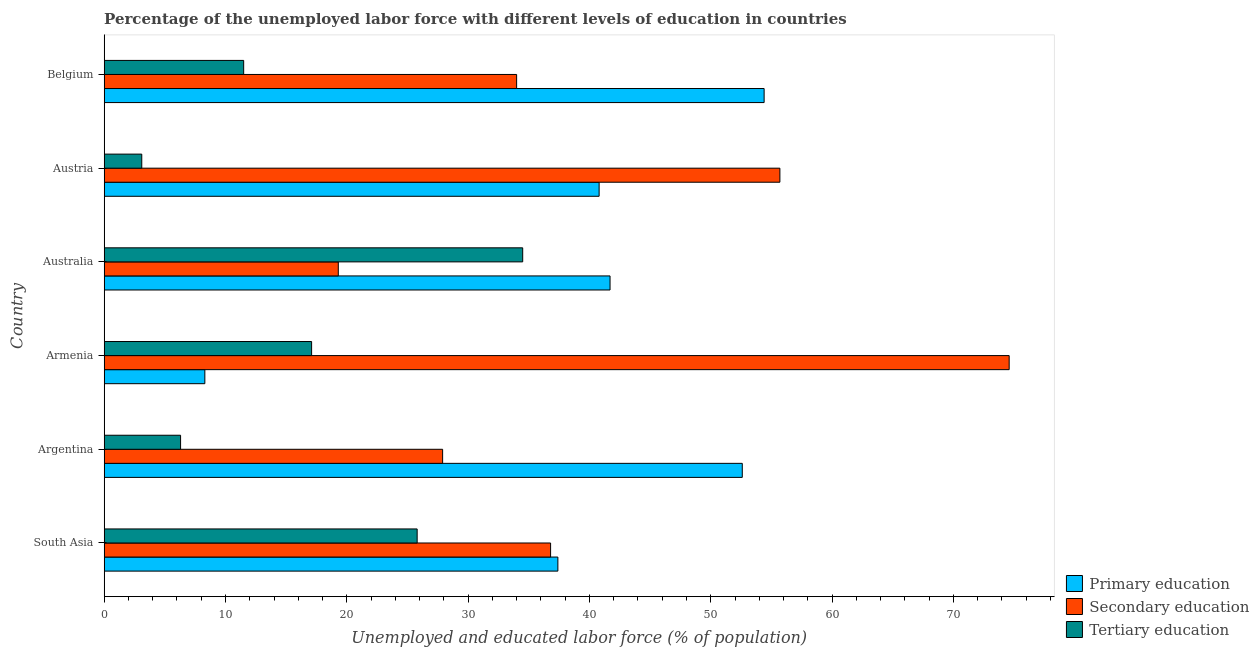How many different coloured bars are there?
Your response must be concise. 3. Are the number of bars on each tick of the Y-axis equal?
Your answer should be very brief. Yes. What is the label of the 5th group of bars from the top?
Offer a very short reply. Argentina. In how many cases, is the number of bars for a given country not equal to the number of legend labels?
Provide a succinct answer. 0. What is the percentage of labor force who received secondary education in Australia?
Offer a terse response. 19.3. Across all countries, what is the maximum percentage of labor force who received secondary education?
Ensure brevity in your answer.  74.6. Across all countries, what is the minimum percentage of labor force who received primary education?
Provide a succinct answer. 8.3. In which country was the percentage of labor force who received primary education maximum?
Your response must be concise. Belgium. What is the total percentage of labor force who received secondary education in the graph?
Offer a terse response. 248.3. What is the difference between the percentage of labor force who received primary education in Belgium and that in South Asia?
Provide a short and direct response. 17. What is the difference between the percentage of labor force who received primary education in Argentina and the percentage of labor force who received tertiary education in Australia?
Keep it short and to the point. 18.1. What is the average percentage of labor force who received primary education per country?
Keep it short and to the point. 39.2. What is the difference between the percentage of labor force who received primary education and percentage of labor force who received secondary education in Belgium?
Offer a terse response. 20.4. What is the ratio of the percentage of labor force who received secondary education in Argentina to that in Australia?
Provide a succinct answer. 1.45. Is the percentage of labor force who received secondary education in Argentina less than that in South Asia?
Provide a short and direct response. Yes. Is the difference between the percentage of labor force who received primary education in Armenia and Belgium greater than the difference between the percentage of labor force who received tertiary education in Armenia and Belgium?
Give a very brief answer. No. What is the difference between the highest and the second highest percentage of labor force who received primary education?
Offer a terse response. 1.8. What is the difference between the highest and the lowest percentage of labor force who received secondary education?
Provide a short and direct response. 55.3. In how many countries, is the percentage of labor force who received secondary education greater than the average percentage of labor force who received secondary education taken over all countries?
Ensure brevity in your answer.  2. What does the 2nd bar from the top in Belgium represents?
Your answer should be compact. Secondary education. What does the 3rd bar from the bottom in Belgium represents?
Offer a very short reply. Tertiary education. Is it the case that in every country, the sum of the percentage of labor force who received primary education and percentage of labor force who received secondary education is greater than the percentage of labor force who received tertiary education?
Your response must be concise. Yes. How many bars are there?
Make the answer very short. 18. How many countries are there in the graph?
Your answer should be very brief. 6. Are the values on the major ticks of X-axis written in scientific E-notation?
Make the answer very short. No. Where does the legend appear in the graph?
Provide a succinct answer. Bottom right. What is the title of the graph?
Offer a terse response. Percentage of the unemployed labor force with different levels of education in countries. Does "Ages 15-64" appear as one of the legend labels in the graph?
Keep it short and to the point. No. What is the label or title of the X-axis?
Offer a very short reply. Unemployed and educated labor force (% of population). What is the Unemployed and educated labor force (% of population) of Primary education in South Asia?
Provide a short and direct response. 37.4. What is the Unemployed and educated labor force (% of population) in Secondary education in South Asia?
Your response must be concise. 36.8. What is the Unemployed and educated labor force (% of population) in Tertiary education in South Asia?
Provide a succinct answer. 25.8. What is the Unemployed and educated labor force (% of population) of Primary education in Argentina?
Provide a short and direct response. 52.6. What is the Unemployed and educated labor force (% of population) of Secondary education in Argentina?
Your response must be concise. 27.9. What is the Unemployed and educated labor force (% of population) of Tertiary education in Argentina?
Provide a short and direct response. 6.3. What is the Unemployed and educated labor force (% of population) in Primary education in Armenia?
Offer a very short reply. 8.3. What is the Unemployed and educated labor force (% of population) of Secondary education in Armenia?
Your answer should be very brief. 74.6. What is the Unemployed and educated labor force (% of population) of Tertiary education in Armenia?
Offer a very short reply. 17.1. What is the Unemployed and educated labor force (% of population) of Primary education in Australia?
Offer a very short reply. 41.7. What is the Unemployed and educated labor force (% of population) in Secondary education in Australia?
Provide a succinct answer. 19.3. What is the Unemployed and educated labor force (% of population) in Tertiary education in Australia?
Your answer should be very brief. 34.5. What is the Unemployed and educated labor force (% of population) of Primary education in Austria?
Ensure brevity in your answer.  40.8. What is the Unemployed and educated labor force (% of population) of Secondary education in Austria?
Your response must be concise. 55.7. What is the Unemployed and educated labor force (% of population) of Tertiary education in Austria?
Your answer should be very brief. 3.1. What is the Unemployed and educated labor force (% of population) of Primary education in Belgium?
Make the answer very short. 54.4. What is the Unemployed and educated labor force (% of population) of Secondary education in Belgium?
Keep it short and to the point. 34. Across all countries, what is the maximum Unemployed and educated labor force (% of population) of Primary education?
Provide a short and direct response. 54.4. Across all countries, what is the maximum Unemployed and educated labor force (% of population) in Secondary education?
Offer a terse response. 74.6. Across all countries, what is the maximum Unemployed and educated labor force (% of population) of Tertiary education?
Provide a short and direct response. 34.5. Across all countries, what is the minimum Unemployed and educated labor force (% of population) in Primary education?
Your answer should be compact. 8.3. Across all countries, what is the minimum Unemployed and educated labor force (% of population) in Secondary education?
Your answer should be compact. 19.3. Across all countries, what is the minimum Unemployed and educated labor force (% of population) in Tertiary education?
Your answer should be compact. 3.1. What is the total Unemployed and educated labor force (% of population) of Primary education in the graph?
Ensure brevity in your answer.  235.2. What is the total Unemployed and educated labor force (% of population) of Secondary education in the graph?
Your response must be concise. 248.3. What is the total Unemployed and educated labor force (% of population) of Tertiary education in the graph?
Make the answer very short. 98.3. What is the difference between the Unemployed and educated labor force (% of population) of Primary education in South Asia and that in Argentina?
Ensure brevity in your answer.  -15.2. What is the difference between the Unemployed and educated labor force (% of population) in Tertiary education in South Asia and that in Argentina?
Your response must be concise. 19.5. What is the difference between the Unemployed and educated labor force (% of population) of Primary education in South Asia and that in Armenia?
Keep it short and to the point. 29.1. What is the difference between the Unemployed and educated labor force (% of population) of Secondary education in South Asia and that in Armenia?
Give a very brief answer. -37.8. What is the difference between the Unemployed and educated labor force (% of population) of Primary education in South Asia and that in Australia?
Ensure brevity in your answer.  -4.3. What is the difference between the Unemployed and educated labor force (% of population) of Tertiary education in South Asia and that in Australia?
Give a very brief answer. -8.7. What is the difference between the Unemployed and educated labor force (% of population) of Secondary education in South Asia and that in Austria?
Ensure brevity in your answer.  -18.9. What is the difference between the Unemployed and educated labor force (% of population) of Tertiary education in South Asia and that in Austria?
Your answer should be very brief. 22.7. What is the difference between the Unemployed and educated labor force (% of population) of Primary education in South Asia and that in Belgium?
Ensure brevity in your answer.  -17. What is the difference between the Unemployed and educated labor force (% of population) of Secondary education in South Asia and that in Belgium?
Your answer should be compact. 2.8. What is the difference between the Unemployed and educated labor force (% of population) of Primary education in Argentina and that in Armenia?
Provide a short and direct response. 44.3. What is the difference between the Unemployed and educated labor force (% of population) of Secondary education in Argentina and that in Armenia?
Your answer should be very brief. -46.7. What is the difference between the Unemployed and educated labor force (% of population) in Secondary education in Argentina and that in Australia?
Offer a very short reply. 8.6. What is the difference between the Unemployed and educated labor force (% of population) in Tertiary education in Argentina and that in Australia?
Ensure brevity in your answer.  -28.2. What is the difference between the Unemployed and educated labor force (% of population) of Secondary education in Argentina and that in Austria?
Your answer should be very brief. -27.8. What is the difference between the Unemployed and educated labor force (% of population) of Primary education in Armenia and that in Australia?
Ensure brevity in your answer.  -33.4. What is the difference between the Unemployed and educated labor force (% of population) in Secondary education in Armenia and that in Australia?
Ensure brevity in your answer.  55.3. What is the difference between the Unemployed and educated labor force (% of population) of Tertiary education in Armenia and that in Australia?
Offer a terse response. -17.4. What is the difference between the Unemployed and educated labor force (% of population) in Primary education in Armenia and that in Austria?
Give a very brief answer. -32.5. What is the difference between the Unemployed and educated labor force (% of population) of Tertiary education in Armenia and that in Austria?
Provide a short and direct response. 14. What is the difference between the Unemployed and educated labor force (% of population) of Primary education in Armenia and that in Belgium?
Your response must be concise. -46.1. What is the difference between the Unemployed and educated labor force (% of population) in Secondary education in Armenia and that in Belgium?
Keep it short and to the point. 40.6. What is the difference between the Unemployed and educated labor force (% of population) of Tertiary education in Armenia and that in Belgium?
Make the answer very short. 5.6. What is the difference between the Unemployed and educated labor force (% of population) in Primary education in Australia and that in Austria?
Provide a succinct answer. 0.9. What is the difference between the Unemployed and educated labor force (% of population) of Secondary education in Australia and that in Austria?
Your answer should be very brief. -36.4. What is the difference between the Unemployed and educated labor force (% of population) in Tertiary education in Australia and that in Austria?
Your answer should be compact. 31.4. What is the difference between the Unemployed and educated labor force (% of population) in Primary education in Australia and that in Belgium?
Offer a very short reply. -12.7. What is the difference between the Unemployed and educated labor force (% of population) in Secondary education in Australia and that in Belgium?
Make the answer very short. -14.7. What is the difference between the Unemployed and educated labor force (% of population) of Primary education in Austria and that in Belgium?
Your response must be concise. -13.6. What is the difference between the Unemployed and educated labor force (% of population) in Secondary education in Austria and that in Belgium?
Offer a terse response. 21.7. What is the difference between the Unemployed and educated labor force (% of population) in Primary education in South Asia and the Unemployed and educated labor force (% of population) in Secondary education in Argentina?
Offer a very short reply. 9.5. What is the difference between the Unemployed and educated labor force (% of population) in Primary education in South Asia and the Unemployed and educated labor force (% of population) in Tertiary education in Argentina?
Make the answer very short. 31.1. What is the difference between the Unemployed and educated labor force (% of population) in Secondary education in South Asia and the Unemployed and educated labor force (% of population) in Tertiary education in Argentina?
Your answer should be compact. 30.5. What is the difference between the Unemployed and educated labor force (% of population) of Primary education in South Asia and the Unemployed and educated labor force (% of population) of Secondary education in Armenia?
Offer a very short reply. -37.2. What is the difference between the Unemployed and educated labor force (% of population) of Primary education in South Asia and the Unemployed and educated labor force (% of population) of Tertiary education in Armenia?
Your response must be concise. 20.3. What is the difference between the Unemployed and educated labor force (% of population) in Primary education in South Asia and the Unemployed and educated labor force (% of population) in Secondary education in Australia?
Give a very brief answer. 18.1. What is the difference between the Unemployed and educated labor force (% of population) of Secondary education in South Asia and the Unemployed and educated labor force (% of population) of Tertiary education in Australia?
Provide a succinct answer. 2.3. What is the difference between the Unemployed and educated labor force (% of population) in Primary education in South Asia and the Unemployed and educated labor force (% of population) in Secondary education in Austria?
Make the answer very short. -18.3. What is the difference between the Unemployed and educated labor force (% of population) of Primary education in South Asia and the Unemployed and educated labor force (% of population) of Tertiary education in Austria?
Offer a terse response. 34.3. What is the difference between the Unemployed and educated labor force (% of population) of Secondary education in South Asia and the Unemployed and educated labor force (% of population) of Tertiary education in Austria?
Make the answer very short. 33.7. What is the difference between the Unemployed and educated labor force (% of population) in Primary education in South Asia and the Unemployed and educated labor force (% of population) in Tertiary education in Belgium?
Offer a terse response. 25.9. What is the difference between the Unemployed and educated labor force (% of population) of Secondary education in South Asia and the Unemployed and educated labor force (% of population) of Tertiary education in Belgium?
Your response must be concise. 25.3. What is the difference between the Unemployed and educated labor force (% of population) in Primary education in Argentina and the Unemployed and educated labor force (% of population) in Tertiary education in Armenia?
Your answer should be compact. 35.5. What is the difference between the Unemployed and educated labor force (% of population) of Secondary education in Argentina and the Unemployed and educated labor force (% of population) of Tertiary education in Armenia?
Provide a succinct answer. 10.8. What is the difference between the Unemployed and educated labor force (% of population) in Primary education in Argentina and the Unemployed and educated labor force (% of population) in Secondary education in Australia?
Your response must be concise. 33.3. What is the difference between the Unemployed and educated labor force (% of population) of Secondary education in Argentina and the Unemployed and educated labor force (% of population) of Tertiary education in Australia?
Offer a terse response. -6.6. What is the difference between the Unemployed and educated labor force (% of population) of Primary education in Argentina and the Unemployed and educated labor force (% of population) of Tertiary education in Austria?
Your response must be concise. 49.5. What is the difference between the Unemployed and educated labor force (% of population) in Secondary education in Argentina and the Unemployed and educated labor force (% of population) in Tertiary education in Austria?
Offer a very short reply. 24.8. What is the difference between the Unemployed and educated labor force (% of population) in Primary education in Argentina and the Unemployed and educated labor force (% of population) in Tertiary education in Belgium?
Make the answer very short. 41.1. What is the difference between the Unemployed and educated labor force (% of population) of Primary education in Armenia and the Unemployed and educated labor force (% of population) of Secondary education in Australia?
Your answer should be very brief. -11. What is the difference between the Unemployed and educated labor force (% of population) in Primary education in Armenia and the Unemployed and educated labor force (% of population) in Tertiary education in Australia?
Ensure brevity in your answer.  -26.2. What is the difference between the Unemployed and educated labor force (% of population) in Secondary education in Armenia and the Unemployed and educated labor force (% of population) in Tertiary education in Australia?
Offer a terse response. 40.1. What is the difference between the Unemployed and educated labor force (% of population) of Primary education in Armenia and the Unemployed and educated labor force (% of population) of Secondary education in Austria?
Offer a terse response. -47.4. What is the difference between the Unemployed and educated labor force (% of population) in Primary education in Armenia and the Unemployed and educated labor force (% of population) in Tertiary education in Austria?
Offer a very short reply. 5.2. What is the difference between the Unemployed and educated labor force (% of population) in Secondary education in Armenia and the Unemployed and educated labor force (% of population) in Tertiary education in Austria?
Your answer should be compact. 71.5. What is the difference between the Unemployed and educated labor force (% of population) in Primary education in Armenia and the Unemployed and educated labor force (% of population) in Secondary education in Belgium?
Your answer should be compact. -25.7. What is the difference between the Unemployed and educated labor force (% of population) in Primary education in Armenia and the Unemployed and educated labor force (% of population) in Tertiary education in Belgium?
Your response must be concise. -3.2. What is the difference between the Unemployed and educated labor force (% of population) in Secondary education in Armenia and the Unemployed and educated labor force (% of population) in Tertiary education in Belgium?
Keep it short and to the point. 63.1. What is the difference between the Unemployed and educated labor force (% of population) of Primary education in Australia and the Unemployed and educated labor force (% of population) of Secondary education in Austria?
Offer a very short reply. -14. What is the difference between the Unemployed and educated labor force (% of population) of Primary education in Australia and the Unemployed and educated labor force (% of population) of Tertiary education in Austria?
Your response must be concise. 38.6. What is the difference between the Unemployed and educated labor force (% of population) of Primary education in Australia and the Unemployed and educated labor force (% of population) of Secondary education in Belgium?
Your response must be concise. 7.7. What is the difference between the Unemployed and educated labor force (% of population) of Primary education in Australia and the Unemployed and educated labor force (% of population) of Tertiary education in Belgium?
Your response must be concise. 30.2. What is the difference between the Unemployed and educated labor force (% of population) of Secondary education in Australia and the Unemployed and educated labor force (% of population) of Tertiary education in Belgium?
Provide a succinct answer. 7.8. What is the difference between the Unemployed and educated labor force (% of population) of Primary education in Austria and the Unemployed and educated labor force (% of population) of Tertiary education in Belgium?
Provide a succinct answer. 29.3. What is the difference between the Unemployed and educated labor force (% of population) in Secondary education in Austria and the Unemployed and educated labor force (% of population) in Tertiary education in Belgium?
Your response must be concise. 44.2. What is the average Unemployed and educated labor force (% of population) in Primary education per country?
Provide a short and direct response. 39.2. What is the average Unemployed and educated labor force (% of population) of Secondary education per country?
Keep it short and to the point. 41.38. What is the average Unemployed and educated labor force (% of population) of Tertiary education per country?
Ensure brevity in your answer.  16.38. What is the difference between the Unemployed and educated labor force (% of population) of Secondary education and Unemployed and educated labor force (% of population) of Tertiary education in South Asia?
Keep it short and to the point. 11. What is the difference between the Unemployed and educated labor force (% of population) in Primary education and Unemployed and educated labor force (% of population) in Secondary education in Argentina?
Provide a succinct answer. 24.7. What is the difference between the Unemployed and educated labor force (% of population) in Primary education and Unemployed and educated labor force (% of population) in Tertiary education in Argentina?
Your response must be concise. 46.3. What is the difference between the Unemployed and educated labor force (% of population) of Secondary education and Unemployed and educated labor force (% of population) of Tertiary education in Argentina?
Provide a succinct answer. 21.6. What is the difference between the Unemployed and educated labor force (% of population) of Primary education and Unemployed and educated labor force (% of population) of Secondary education in Armenia?
Offer a terse response. -66.3. What is the difference between the Unemployed and educated labor force (% of population) of Secondary education and Unemployed and educated labor force (% of population) of Tertiary education in Armenia?
Give a very brief answer. 57.5. What is the difference between the Unemployed and educated labor force (% of population) in Primary education and Unemployed and educated labor force (% of population) in Secondary education in Australia?
Provide a succinct answer. 22.4. What is the difference between the Unemployed and educated labor force (% of population) of Primary education and Unemployed and educated labor force (% of population) of Tertiary education in Australia?
Ensure brevity in your answer.  7.2. What is the difference between the Unemployed and educated labor force (% of population) of Secondary education and Unemployed and educated labor force (% of population) of Tertiary education in Australia?
Provide a short and direct response. -15.2. What is the difference between the Unemployed and educated labor force (% of population) in Primary education and Unemployed and educated labor force (% of population) in Secondary education in Austria?
Your answer should be compact. -14.9. What is the difference between the Unemployed and educated labor force (% of population) in Primary education and Unemployed and educated labor force (% of population) in Tertiary education in Austria?
Provide a succinct answer. 37.7. What is the difference between the Unemployed and educated labor force (% of population) in Secondary education and Unemployed and educated labor force (% of population) in Tertiary education in Austria?
Make the answer very short. 52.6. What is the difference between the Unemployed and educated labor force (% of population) of Primary education and Unemployed and educated labor force (% of population) of Secondary education in Belgium?
Keep it short and to the point. 20.4. What is the difference between the Unemployed and educated labor force (% of population) in Primary education and Unemployed and educated labor force (% of population) in Tertiary education in Belgium?
Give a very brief answer. 42.9. What is the ratio of the Unemployed and educated labor force (% of population) in Primary education in South Asia to that in Argentina?
Your answer should be very brief. 0.71. What is the ratio of the Unemployed and educated labor force (% of population) in Secondary education in South Asia to that in Argentina?
Offer a very short reply. 1.32. What is the ratio of the Unemployed and educated labor force (% of population) in Tertiary education in South Asia to that in Argentina?
Your answer should be very brief. 4.1. What is the ratio of the Unemployed and educated labor force (% of population) of Primary education in South Asia to that in Armenia?
Offer a very short reply. 4.51. What is the ratio of the Unemployed and educated labor force (% of population) in Secondary education in South Asia to that in Armenia?
Provide a succinct answer. 0.49. What is the ratio of the Unemployed and educated labor force (% of population) in Tertiary education in South Asia to that in Armenia?
Keep it short and to the point. 1.51. What is the ratio of the Unemployed and educated labor force (% of population) of Primary education in South Asia to that in Australia?
Offer a very short reply. 0.9. What is the ratio of the Unemployed and educated labor force (% of population) of Secondary education in South Asia to that in Australia?
Make the answer very short. 1.91. What is the ratio of the Unemployed and educated labor force (% of population) of Tertiary education in South Asia to that in Australia?
Offer a terse response. 0.75. What is the ratio of the Unemployed and educated labor force (% of population) of Secondary education in South Asia to that in Austria?
Keep it short and to the point. 0.66. What is the ratio of the Unemployed and educated labor force (% of population) in Tertiary education in South Asia to that in Austria?
Offer a terse response. 8.32. What is the ratio of the Unemployed and educated labor force (% of population) of Primary education in South Asia to that in Belgium?
Ensure brevity in your answer.  0.69. What is the ratio of the Unemployed and educated labor force (% of population) of Secondary education in South Asia to that in Belgium?
Provide a succinct answer. 1.08. What is the ratio of the Unemployed and educated labor force (% of population) of Tertiary education in South Asia to that in Belgium?
Provide a short and direct response. 2.24. What is the ratio of the Unemployed and educated labor force (% of population) in Primary education in Argentina to that in Armenia?
Provide a short and direct response. 6.34. What is the ratio of the Unemployed and educated labor force (% of population) of Secondary education in Argentina to that in Armenia?
Your answer should be compact. 0.37. What is the ratio of the Unemployed and educated labor force (% of population) in Tertiary education in Argentina to that in Armenia?
Make the answer very short. 0.37. What is the ratio of the Unemployed and educated labor force (% of population) of Primary education in Argentina to that in Australia?
Your response must be concise. 1.26. What is the ratio of the Unemployed and educated labor force (% of population) of Secondary education in Argentina to that in Australia?
Offer a very short reply. 1.45. What is the ratio of the Unemployed and educated labor force (% of population) of Tertiary education in Argentina to that in Australia?
Offer a terse response. 0.18. What is the ratio of the Unemployed and educated labor force (% of population) in Primary education in Argentina to that in Austria?
Make the answer very short. 1.29. What is the ratio of the Unemployed and educated labor force (% of population) of Secondary education in Argentina to that in Austria?
Ensure brevity in your answer.  0.5. What is the ratio of the Unemployed and educated labor force (% of population) of Tertiary education in Argentina to that in Austria?
Keep it short and to the point. 2.03. What is the ratio of the Unemployed and educated labor force (% of population) in Primary education in Argentina to that in Belgium?
Keep it short and to the point. 0.97. What is the ratio of the Unemployed and educated labor force (% of population) of Secondary education in Argentina to that in Belgium?
Ensure brevity in your answer.  0.82. What is the ratio of the Unemployed and educated labor force (% of population) of Tertiary education in Argentina to that in Belgium?
Make the answer very short. 0.55. What is the ratio of the Unemployed and educated labor force (% of population) in Primary education in Armenia to that in Australia?
Give a very brief answer. 0.2. What is the ratio of the Unemployed and educated labor force (% of population) in Secondary education in Armenia to that in Australia?
Your response must be concise. 3.87. What is the ratio of the Unemployed and educated labor force (% of population) in Tertiary education in Armenia to that in Australia?
Ensure brevity in your answer.  0.5. What is the ratio of the Unemployed and educated labor force (% of population) in Primary education in Armenia to that in Austria?
Provide a succinct answer. 0.2. What is the ratio of the Unemployed and educated labor force (% of population) of Secondary education in Armenia to that in Austria?
Your response must be concise. 1.34. What is the ratio of the Unemployed and educated labor force (% of population) in Tertiary education in Armenia to that in Austria?
Provide a short and direct response. 5.52. What is the ratio of the Unemployed and educated labor force (% of population) of Primary education in Armenia to that in Belgium?
Your response must be concise. 0.15. What is the ratio of the Unemployed and educated labor force (% of population) of Secondary education in Armenia to that in Belgium?
Your response must be concise. 2.19. What is the ratio of the Unemployed and educated labor force (% of population) in Tertiary education in Armenia to that in Belgium?
Keep it short and to the point. 1.49. What is the ratio of the Unemployed and educated labor force (% of population) in Primary education in Australia to that in Austria?
Offer a terse response. 1.02. What is the ratio of the Unemployed and educated labor force (% of population) in Secondary education in Australia to that in Austria?
Give a very brief answer. 0.35. What is the ratio of the Unemployed and educated labor force (% of population) of Tertiary education in Australia to that in Austria?
Your answer should be compact. 11.13. What is the ratio of the Unemployed and educated labor force (% of population) of Primary education in Australia to that in Belgium?
Your answer should be very brief. 0.77. What is the ratio of the Unemployed and educated labor force (% of population) of Secondary education in Australia to that in Belgium?
Your answer should be very brief. 0.57. What is the ratio of the Unemployed and educated labor force (% of population) in Tertiary education in Australia to that in Belgium?
Provide a succinct answer. 3. What is the ratio of the Unemployed and educated labor force (% of population) in Primary education in Austria to that in Belgium?
Your answer should be compact. 0.75. What is the ratio of the Unemployed and educated labor force (% of population) of Secondary education in Austria to that in Belgium?
Provide a succinct answer. 1.64. What is the ratio of the Unemployed and educated labor force (% of population) of Tertiary education in Austria to that in Belgium?
Offer a very short reply. 0.27. What is the difference between the highest and the second highest Unemployed and educated labor force (% of population) in Tertiary education?
Offer a terse response. 8.7. What is the difference between the highest and the lowest Unemployed and educated labor force (% of population) of Primary education?
Offer a terse response. 46.1. What is the difference between the highest and the lowest Unemployed and educated labor force (% of population) in Secondary education?
Provide a succinct answer. 55.3. What is the difference between the highest and the lowest Unemployed and educated labor force (% of population) in Tertiary education?
Ensure brevity in your answer.  31.4. 